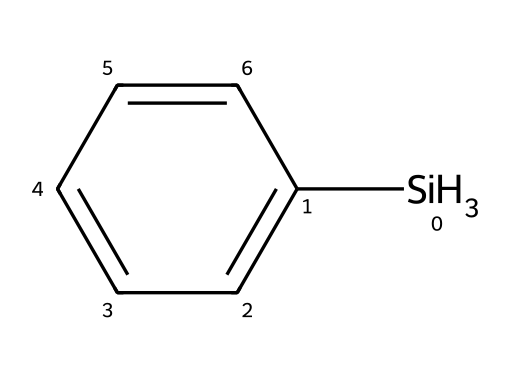What is the molecular formula of phenylsilane? The molecular formula is determined by counting the number of each type of atom present in the structure. In the given SMILES, there are 7 carbon atoms, 3 hydrogen atoms from the silane part, and 5 hydrogen atoms from the phenyl group, leading to the formula C6H5SiH3.
Answer: C6H5SiH3 How many hydrogen atoms are in phenylsilane? Counting the hydrogen atoms in the SMILES representation shows there are a total of 8 hydrogen atoms: 5 from the phenyl group and 3 from the silane part.
Answer: 8 What type of chemical bond is present between silicon and carbon in phenylsilane? The bond type is determined by the connectivity shown in the structure. The silicon atom is directly connected to the phenyl group, indicating a covalent bond.
Answer: covalent What is the significance of the phenyl group in phenylsilane? The phenyl group contributes to the aromatic stability and can influence solubility and reactivity of silanes in chemical reactions, especially in optical lens applications.
Answer: aromatic stability Is phenylsilane a solid, liquid, or gas at room temperature? To determine this, one considers the structures of similar silanes and their physical properties, where phenylsilane is generally known to be a liquid at room temperature due to low molecular weight.
Answer: liquid How does the presence of the silane group affect the properties of the phenyl group? The silane group enhances reactivity and can improve the adhesion of phenylsilane to various substrates, which is useful in the development of optical coatings.
Answer: improves adhesion 